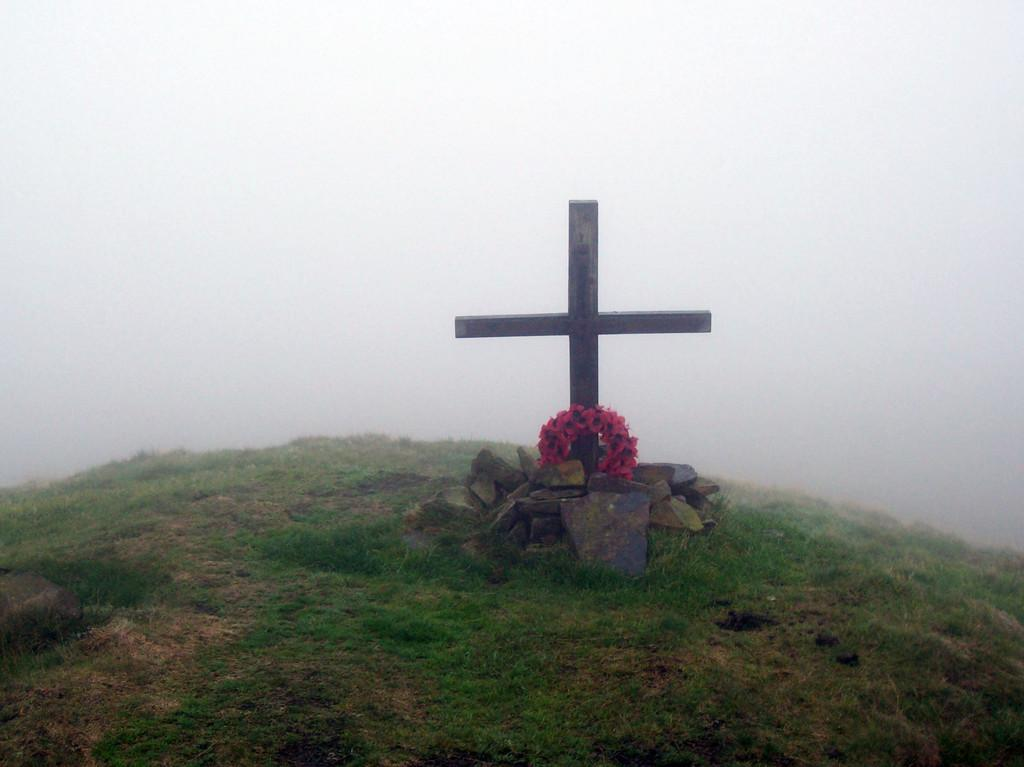What can be seen in the picture? There is a grave in the picture. What is placed on the grave? A pink garland is placed on the grave. What is near the grave? There is a cross near the grave. What is the background of the picture? There is snow behind the grave. What type of carpenter is working on the team in the picture? There is no carpenter or team present in the picture; it features a grave with a pink garland and a cross. What noise can be heard coming from the grave in the picture? There is no noise coming from the grave in the picture; it is a still image. 